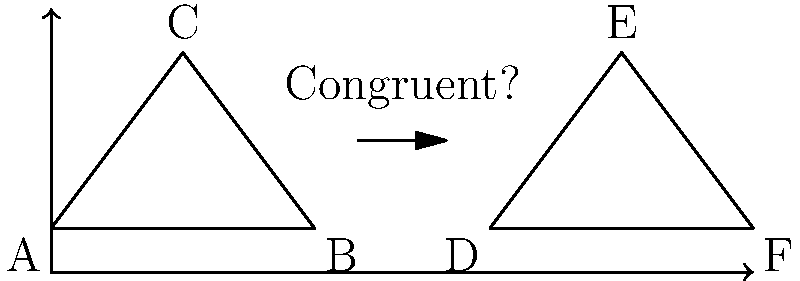In this stylized illustration of a quill pen and inkwell, two triangles are shown. Triangle ABC represents the quill, and triangle DEF represents the inkwell. Are these triangles congruent? If so, which congruence criterion can be used to prove it? To determine if triangles ABC and DEF are congruent, we need to examine their sides and angles. Let's follow these steps:

1. Observe that both triangles appear to have the same shape and size.

2. In triangle ABC:
   - Side AB is the base of the quill
   - Side BC is one side of the quill's tip
   - Side AC is the other side of the quill's tip

3. In triangle DEF:
   - Side DF is the base of the inkwell
   - Side DE is one side of the inkwell's opening
   - Side EF is the other side of the inkwell's opening

4. Comparing the triangles:
   - AB appears to be equal in length to DF
   - BC appears to be equal in length to DE
   - AC appears to be equal in length to EF

5. Since all three sides of triangle ABC appear to be equal to the corresponding sides of triangle DEF, we can use the Side-Side-Side (SSS) congruence criterion.

6. The SSS criterion states that if three sides of one triangle are equal to three sides of another triangle, then the triangles are congruent.

Therefore, based on the illustration, triangles ABC and DEF appear to be congruent, and we can use the SSS congruence criterion to prove it.
Answer: Yes, SSS criterion 